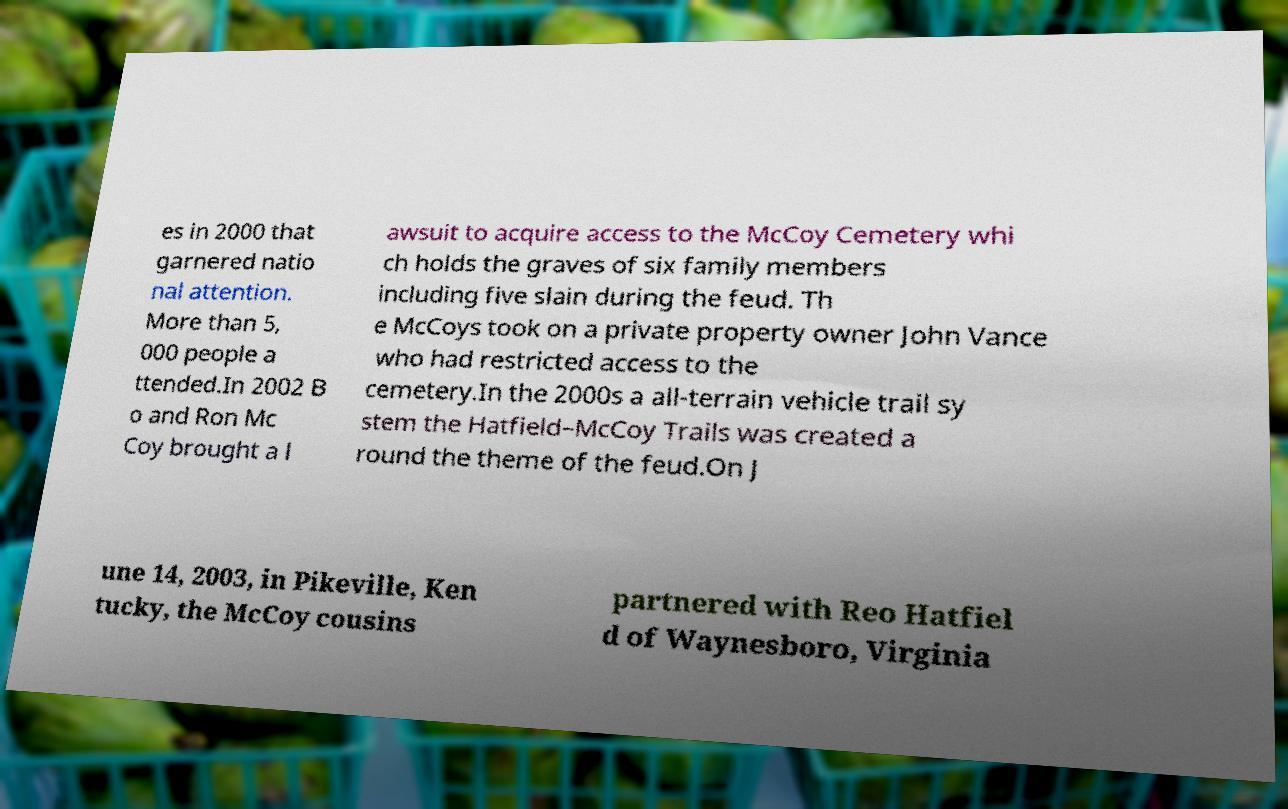Please read and relay the text visible in this image. What does it say? es in 2000 that garnered natio nal attention. More than 5, 000 people a ttended.In 2002 B o and Ron Mc Coy brought a l awsuit to acquire access to the McCoy Cemetery whi ch holds the graves of six family members including five slain during the feud. Th e McCoys took on a private property owner John Vance who had restricted access to the cemetery.In the 2000s a all-terrain vehicle trail sy stem the Hatfield–McCoy Trails was created a round the theme of the feud.On J une 14, 2003, in Pikeville, Ken tucky, the McCoy cousins partnered with Reo Hatfiel d of Waynesboro, Virginia 